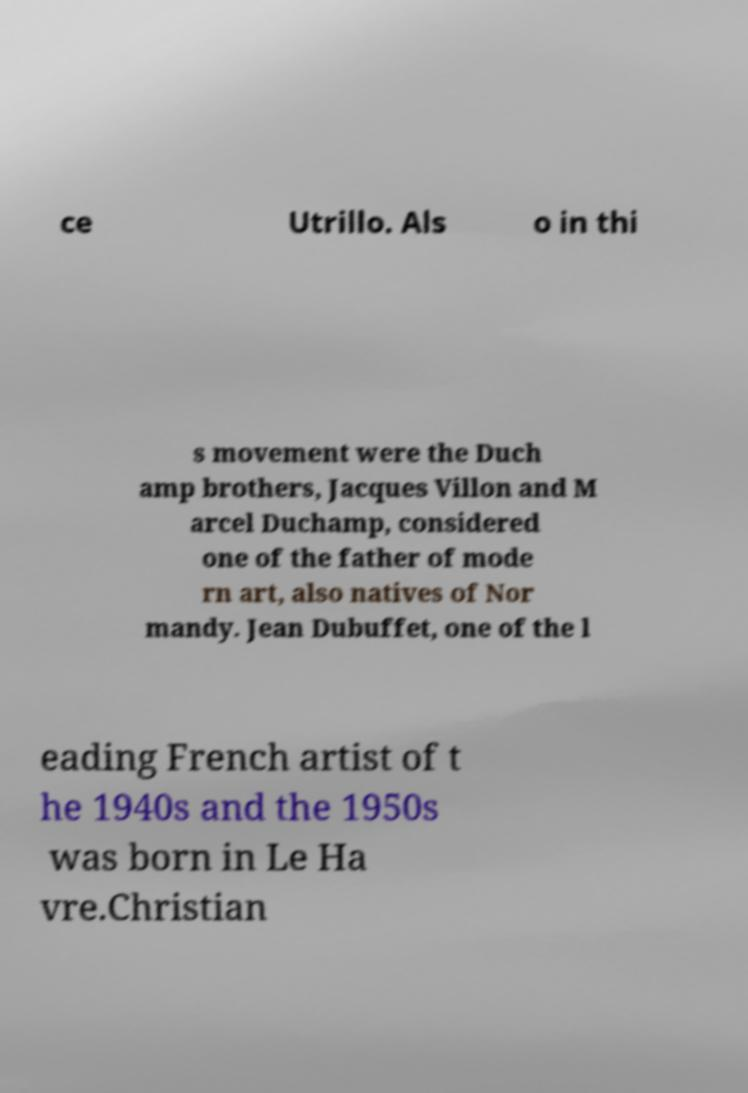Please identify and transcribe the text found in this image. ce Utrillo. Als o in thi s movement were the Duch amp brothers, Jacques Villon and M arcel Duchamp, considered one of the father of mode rn art, also natives of Nor mandy. Jean Dubuffet, one of the l eading French artist of t he 1940s and the 1950s was born in Le Ha vre.Christian 